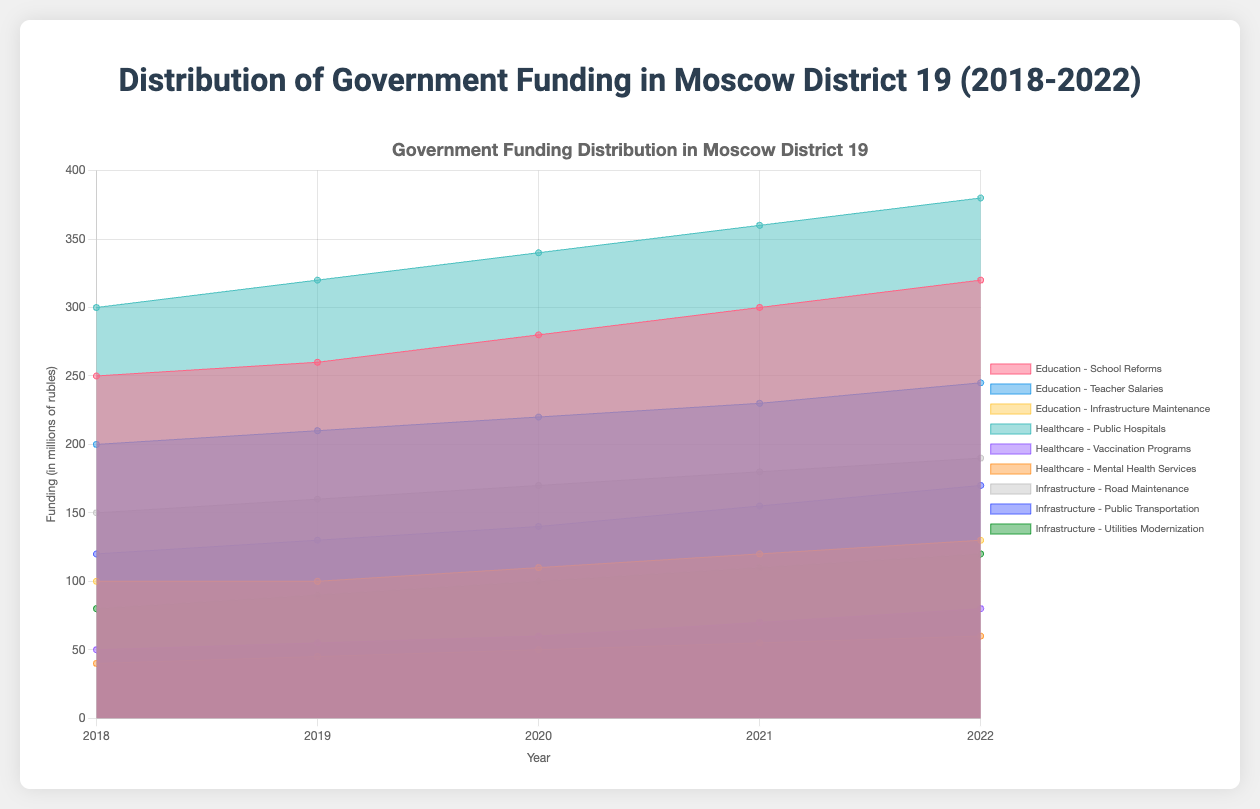What are the three sectors represented in the chart? The chart shows the distribution of government funding across three key public sectors within Moscow District 19 over the past 5 years. The sectors represented are labeled distinctly in different colors within the legend of the chart.
Answer: Education, Healthcare, Infrastructure Which sector had the highest funding allocation in 2022? To determine this, observe the different colored areas representing the three sectors on the chart for the year 2022. Compare the height of each sector's final data point and identify the tallest one.
Answer: Healthcare How much funding was allocated to Teacher Salaries in 2019? Locate the segment for Education, then find the sub-segment labeled "Teacher Salaries" for the year 2019. Refer to the vertical axis to determine the funding amount.
Answer: 210 What's the total funding allocated to Mental Health Services over the 5 years? Add the yearly funding amounts for Mental Health Services from 2018 to 2022. The funding amounts are: 40 + 45 + 50 + 55 + 60. Summing these gives the total funding.
Answer: 250 By how much did funding for Public Transportation increase from 2018 to 2022? Find the funding values for Public Transportation in 2018 and 2022 on the chart, then subtract the former from the latter (170 - 120).
Answer: 50 Which category within Education saw the largest absolute increase in funding from 2018 to 2022? Compare the funding values for "School Reforms," "Teacher Salaries," and "Infrastructure Maintenance" between 2018 and 2022. The increases are: (320-250), (245-200), and (130-100). Identify the category with the largest difference.
Answer: School Reforms How did the funding trend for Vaccination Programs change over the years? Observe the funding amounts specified for Vaccination Programs from 2018 to 2022. Note the trend, which shows an increasing pattern year by year.
Answer: Increasing What is the average annual funding for Road Maintenance over the 5 years? Sum the annual funding for Road Maintenance from 2018 to 2022 (150 + 160 + 170 + 180 + 190) and divide by 5. The sum is 850; dividing 850 by 5 gives the average.
Answer: 170 How does the funding for Public Hospitals in 2021 compare with that for School Reforms in the same year? Locate the funding values for Public Hospitals and School Reforms for the year 2021 on the chart. Public Hospitals received 360, and School Reforms got 300.
Answer: Public Hospitals received more What was the trend of government funding for Utilities Modernization from 2018 to 2022? Examine the funding values for Utilities Modernization over the years: 80, 90, 100, 110, 120. Observe if the values are increasing or decreasing.
Answer: Increasing 